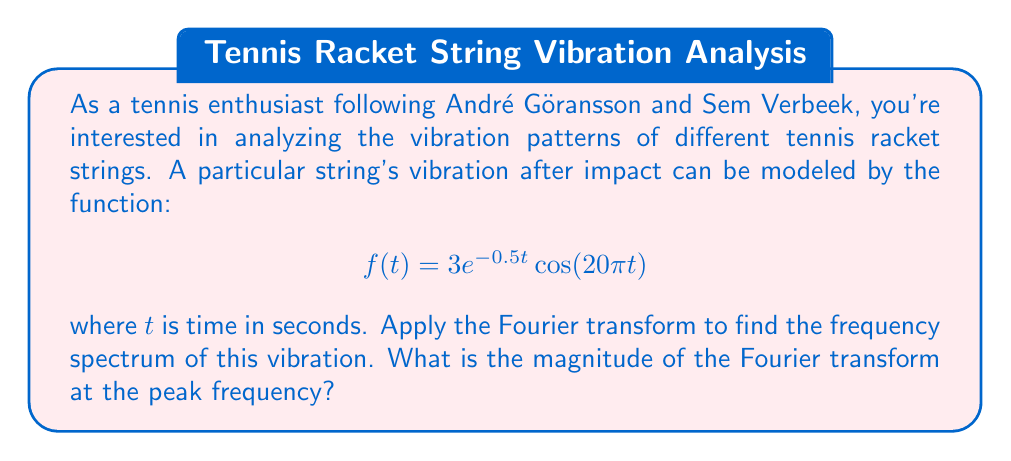Give your solution to this math problem. To solve this problem, we'll follow these steps:

1) The Fourier transform of $f(t) = 3e^{-0.5t}\cos(20\pi t)$ is given by:

   $$F(\omega) = \int_{-\infty}^{\infty} 3e^{-0.5t}\cos(20\pi t)e^{-i\omega t}dt$$

2) This integral can be solved using the Fourier transform of a damped cosine function:

   For $f(t) = e^{-at}\cos(bt)$, the Fourier transform is:

   $$F(\omega) = \frac{a}{a^2 + (b-\omega)^2} + \frac{a}{a^2 + (b+\omega)^2}$$

3) In our case, $a = 0.5$, $b = 20\pi$, and we have a factor of 3. So:

   $$F(\omega) = 3 \cdot \left(\frac{0.5}{0.5^2 + (20\pi-\omega)^2} + \frac{0.5}{0.5^2 + (20\pi+\omega)^2}\right)$$

4) The magnitude of the Fourier transform is given by $|F(\omega)|$. The peak frequency will occur at $\omega = 20\pi$ (positive peak) and $\omega = -20\pi$ (negative peak).

5) Let's calculate $|F(20\pi)|$:

   $$|F(20\pi)| = 3 \cdot \left(\frac{0.5}{0.5^2 + 0^2} + \frac{0.5}{0.5^2 + (40\pi)^2}\right)$$

6) Simplifying:

   $$|F(20\pi)| = 3 \cdot \left(2 + \frac{0.5}{0.25 + 1600\pi^2}\right)$$

7) The second term is negligibly small compared to 2, so we can approximate:

   $$|F(20\pi)| \approx 3 \cdot 2 = 6$$

Therefore, the magnitude of the Fourier transform at the peak frequency is approximately 6.
Answer: The magnitude of the Fourier transform at the peak frequency is approximately 6. 